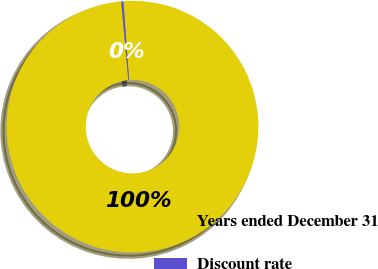Convert chart. <chart><loc_0><loc_0><loc_500><loc_500><pie_chart><fcel>Years ended December 31<fcel>Discount rate<nl><fcel>99.73%<fcel>0.27%<nl></chart> 